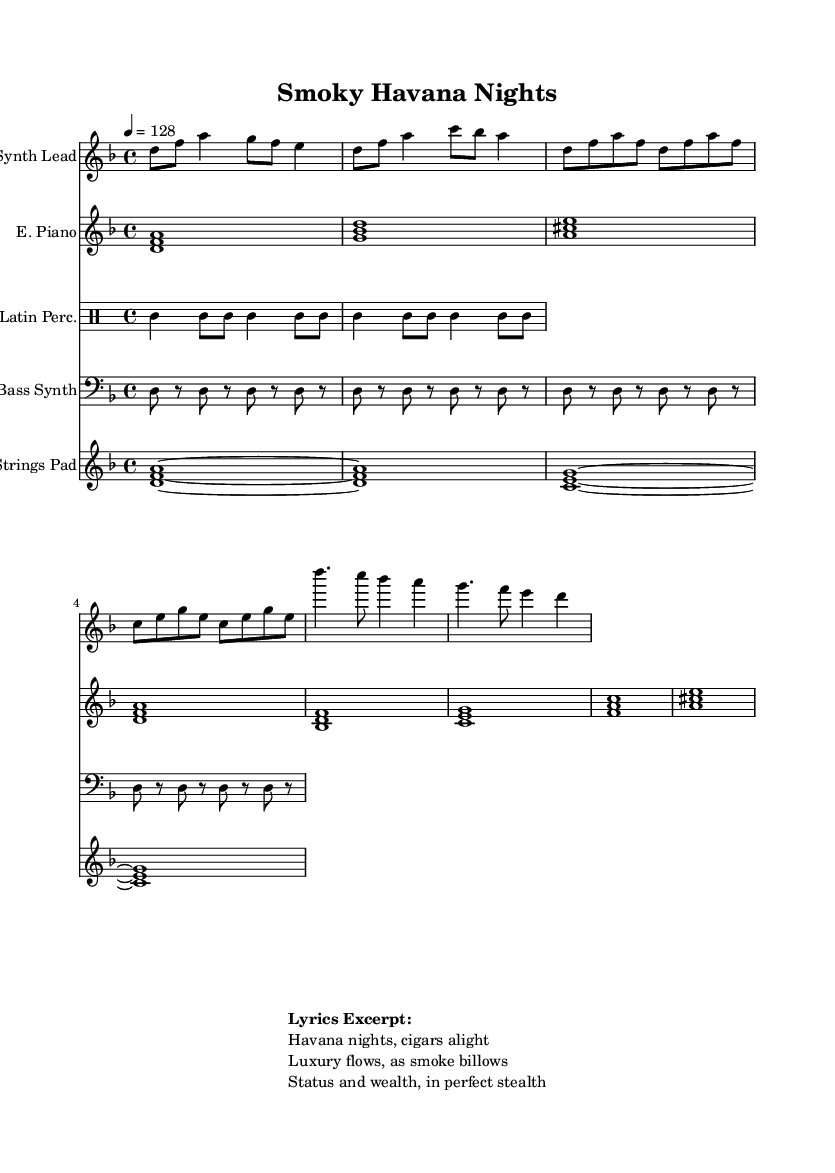What is the key signature of this music? The key signature is indicated at the beginning of the score, showing two flats (B flat and E flat), which signifies the key of D minor.
Answer: D minor What is the time signature of this music? The time signature is found at the beginning of the score and indicates that each measure contains four beats, making it a 4/4 time signature.
Answer: 4/4 What is the tempo marking of this piece? The tempo marking is given in the global section of the score, where it states that the tempo is set to 128 beats per minute.
Answer: 128 How many instruments are present in the score? The score lists five distinct instrumental parts, including Synth Lead, Electric Piano, Bass Synth, Latin Percussion, and Strings Pad.
Answer: Five Which section features the electric piano? The electric piano part is written under the "E. Piano" label in the staff and follows a chord pattern format, indicating its unique place in the score.
Answer: E. Piano What types of rhythmic elements are used in the percussion section? The percussion section utilizes a repeating rhythm structure, with a focus on the timbale sound indicated by the "timh" notation, which is characteristic of Latin music styles.
Answer: Timbales What do the lyrics in the markup suggest about the theme of the piece? The lyrics refer to "Havana nights" and luxury, suggesting themes of indulgence, fine living, and the connections between wealth and status reflected through the enjoyment of cigars and luxury lifestyles.
Answer: Luxury lifestyle 